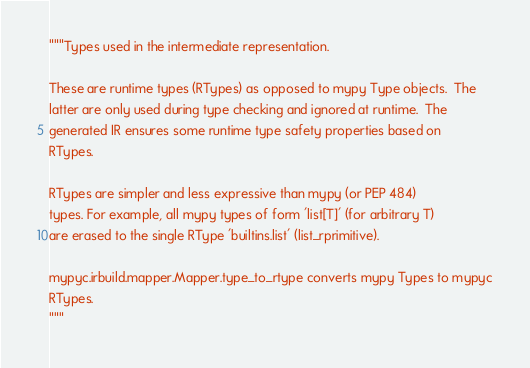Convert code to text. <code><loc_0><loc_0><loc_500><loc_500><_Python_>"""Types used in the intermediate representation.

These are runtime types (RTypes) as opposed to mypy Type objects.  The
latter are only used during type checking and ignored at runtime.  The
generated IR ensures some runtime type safety properties based on
RTypes.

RTypes are simpler and less expressive than mypy (or PEP 484)
types. For example, all mypy types of form 'list[T]' (for arbitrary T)
are erased to the single RType 'builtins.list' (list_rprimitive).

mypyc.irbuild.mapper.Mapper.type_to_rtype converts mypy Types to mypyc
RTypes.
"""
</code> 